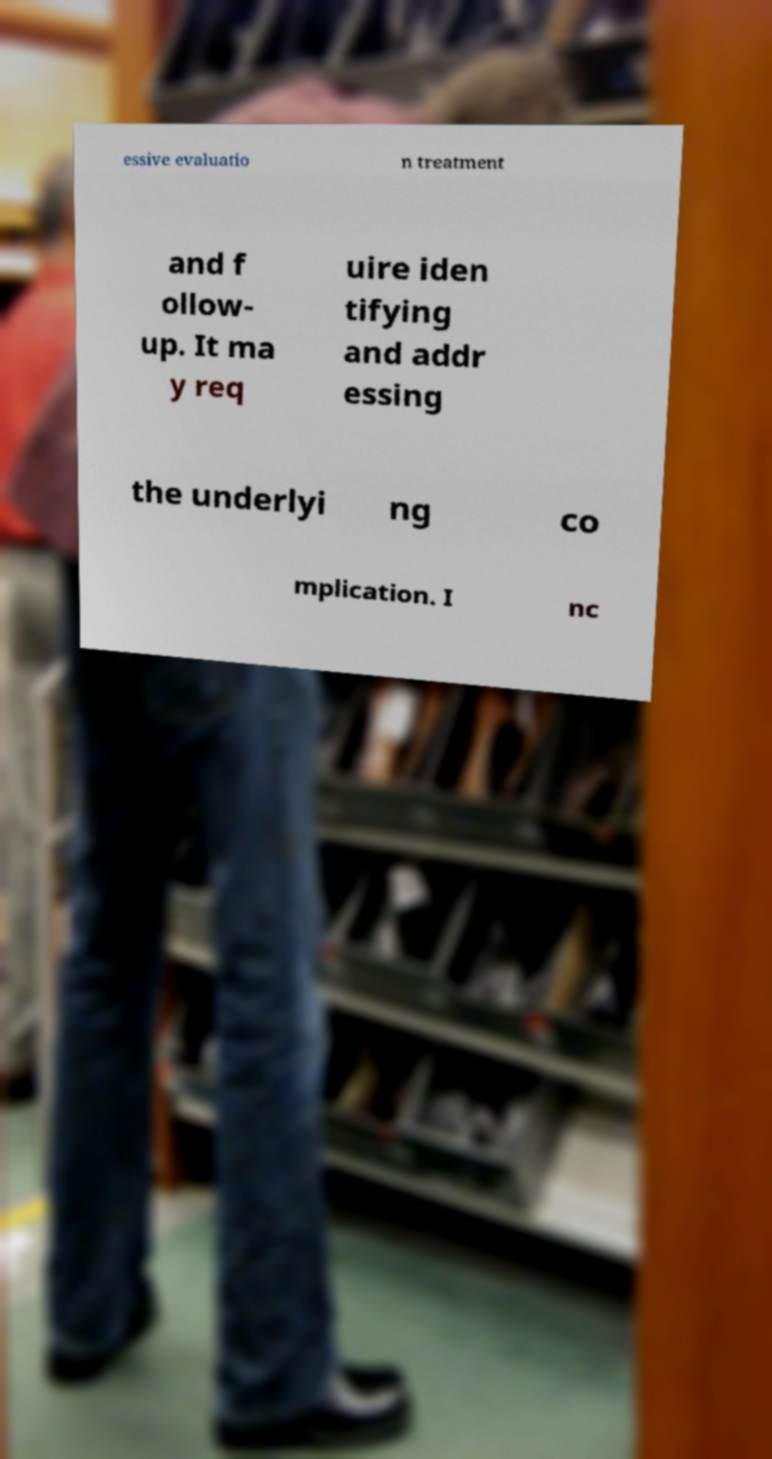Can you read and provide the text displayed in the image?This photo seems to have some interesting text. Can you extract and type it out for me? essive evaluatio n treatment and f ollow- up. It ma y req uire iden tifying and addr essing the underlyi ng co mplication. I nc 